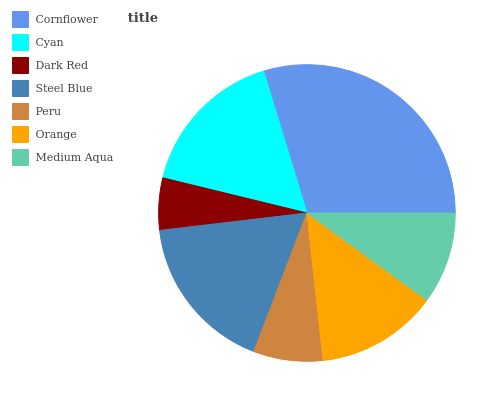Is Dark Red the minimum?
Answer yes or no. Yes. Is Cornflower the maximum?
Answer yes or no. Yes. Is Cyan the minimum?
Answer yes or no. No. Is Cyan the maximum?
Answer yes or no. No. Is Cornflower greater than Cyan?
Answer yes or no. Yes. Is Cyan less than Cornflower?
Answer yes or no. Yes. Is Cyan greater than Cornflower?
Answer yes or no. No. Is Cornflower less than Cyan?
Answer yes or no. No. Is Orange the high median?
Answer yes or no. Yes. Is Orange the low median?
Answer yes or no. Yes. Is Dark Red the high median?
Answer yes or no. No. Is Steel Blue the low median?
Answer yes or no. No. 